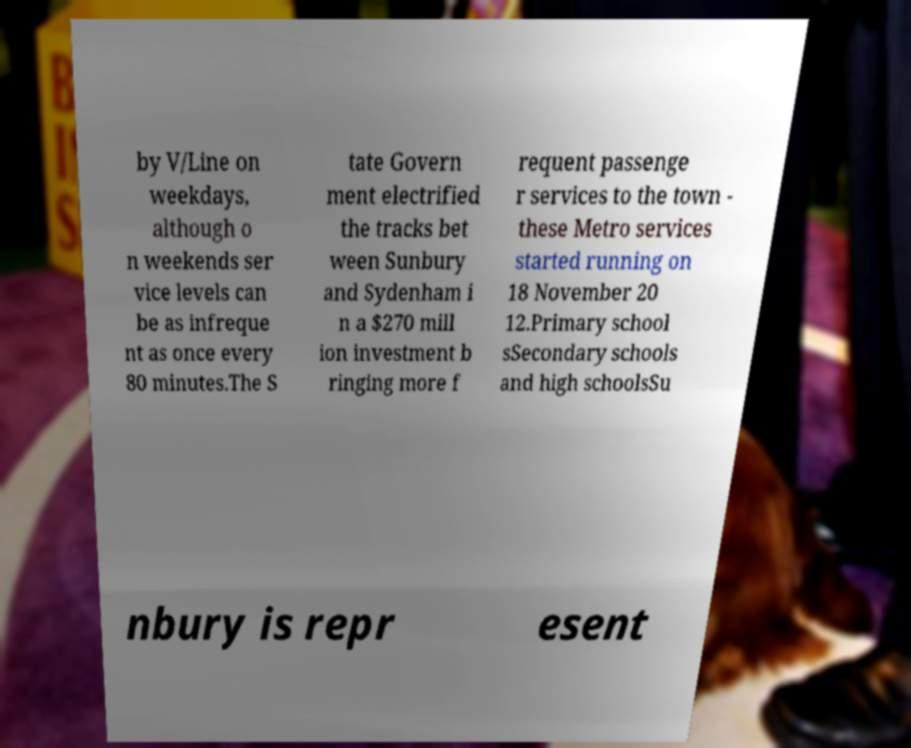What messages or text are displayed in this image? I need them in a readable, typed format. by V/Line on weekdays, although o n weekends ser vice levels can be as infreque nt as once every 80 minutes.The S tate Govern ment electrified the tracks bet ween Sunbury and Sydenham i n a $270 mill ion investment b ringing more f requent passenge r services to the town - these Metro services started running on 18 November 20 12.Primary school sSecondary schools and high schoolsSu nbury is repr esent 